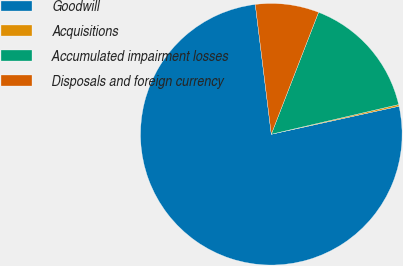Convert chart. <chart><loc_0><loc_0><loc_500><loc_500><pie_chart><fcel>Goodwill<fcel>Acquisitions<fcel>Accumulated impairment losses<fcel>Disposals and foreign currency<nl><fcel>76.48%<fcel>0.21%<fcel>15.47%<fcel>7.84%<nl></chart> 